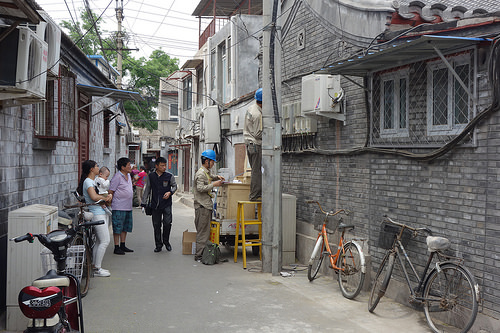<image>
Can you confirm if the woman is on the bike? No. The woman is not positioned on the bike. They may be near each other, but the woman is not supported by or resting on top of the bike. Is the bicycle next to the man? No. The bicycle is not positioned next to the man. They are located in different areas of the scene. 